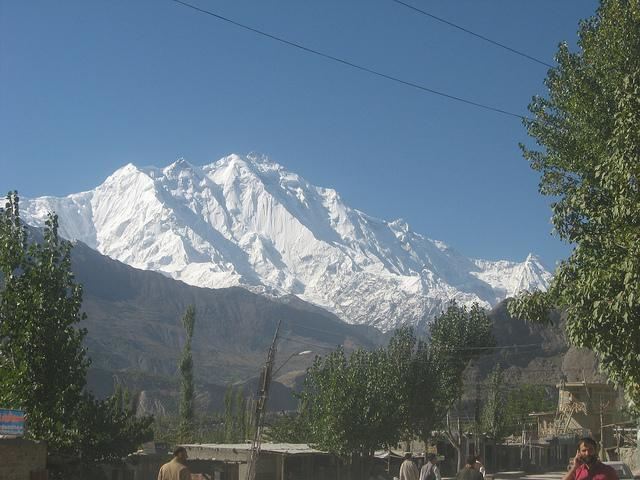Why is there snow up there? cold 